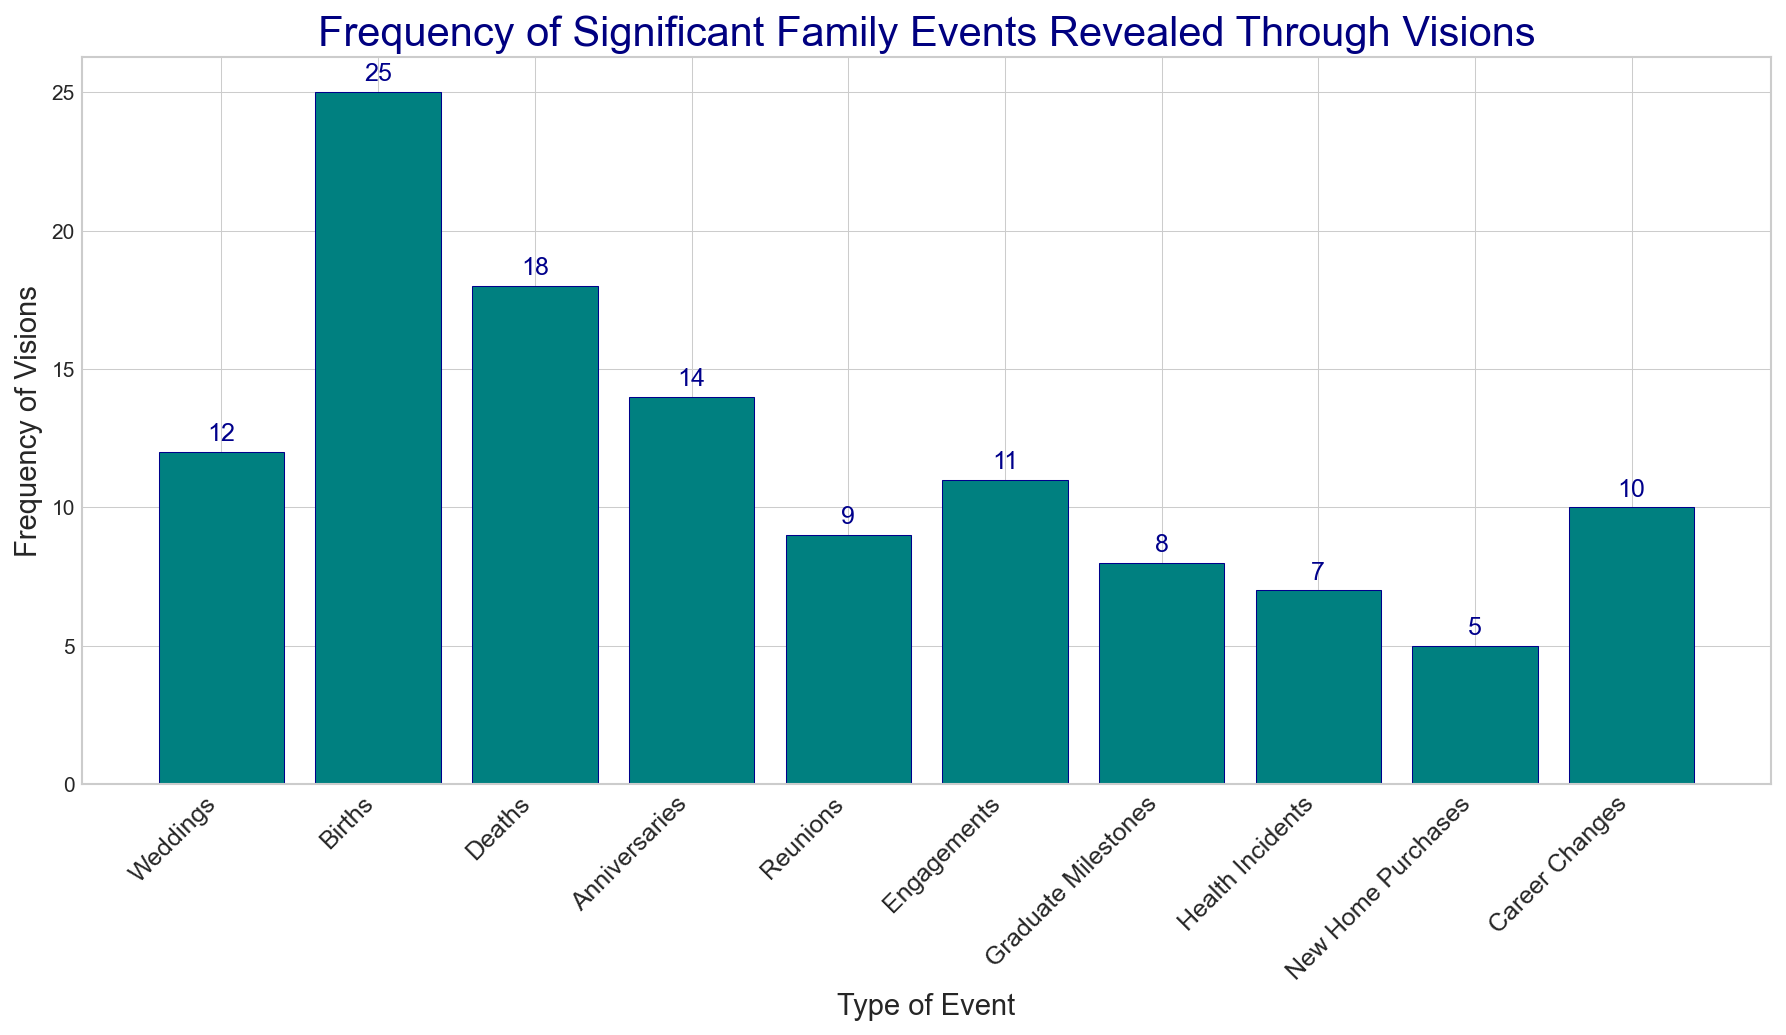Which type of event has the highest frequency of visions? The event type with the highest frequency of visions is represented by the tallest bar in the chart. The bar labeled "Births" is the tallest with a height of 25.
Answer: Births Which event has the lowest frequency of visions? The event with the lowest frequency of visions is represented by the shortest bar in the chart. The bar labeled "New Home Purchases" is the shortest with a height of 5.
Answer: New Home Purchases How many more visions are related to Births than to Health Incidents? Births have 25 visions, and Health Incidents have 7 visions. The difference is calculated by subtracting 7 from 25.
Answer: 18 What is the total frequency of visions for Weddings and Anniversaries combined? Weddings have 12 visions and Anniversaries have 14 visions. The sum of the frequencies is 12 + 14.
Answer: 26 Which two types of events have equal frequencies of visions? By inspecting the bar heights and labels, we can see that no two bars have the exact same height.
Answer: None Are there more visions related to Reunions or Career Changes? The bar for Career Changes is taller than the bar for Reunions. Career Changes have 10 visions, while Reunions have 9.
Answer: Career Changes What's the average frequency of visions for Weddings, Births, and Deaths? The sum of frequencies for Weddings (12), Births (25), and Deaths (18) is 55. The average is calculated by dividing 55 by the number of events (3).
Answer: 18.33 What is the combined frequency of visions for all events with frequencies greater than 10? The events with frequencies greater than 10 are Weddings (12), Births (25), Deaths (18), Anniversaries (14), and Engagements (11). The sum of these frequencies is 12 + 25 + 18 + 14 + 11.
Answer: 80 How does the frequency of visions for Graduate Milestones compare to that for Career Changes? Graduate Milestones have 8 visions and Career Changes have 10 visions. Graduate Milestones have 2 fewer visions than Career Changes.
Answer: 2 fewer What is the median frequency of visions for all event types? The frequencies sorted in ascending order are 5, 7, 8, 9, 10, 11, 12, 14, 18, 25. There are 10 data points, so the median is the average of the 5th and 6th values (10 and 11).
Answer: 10.5 